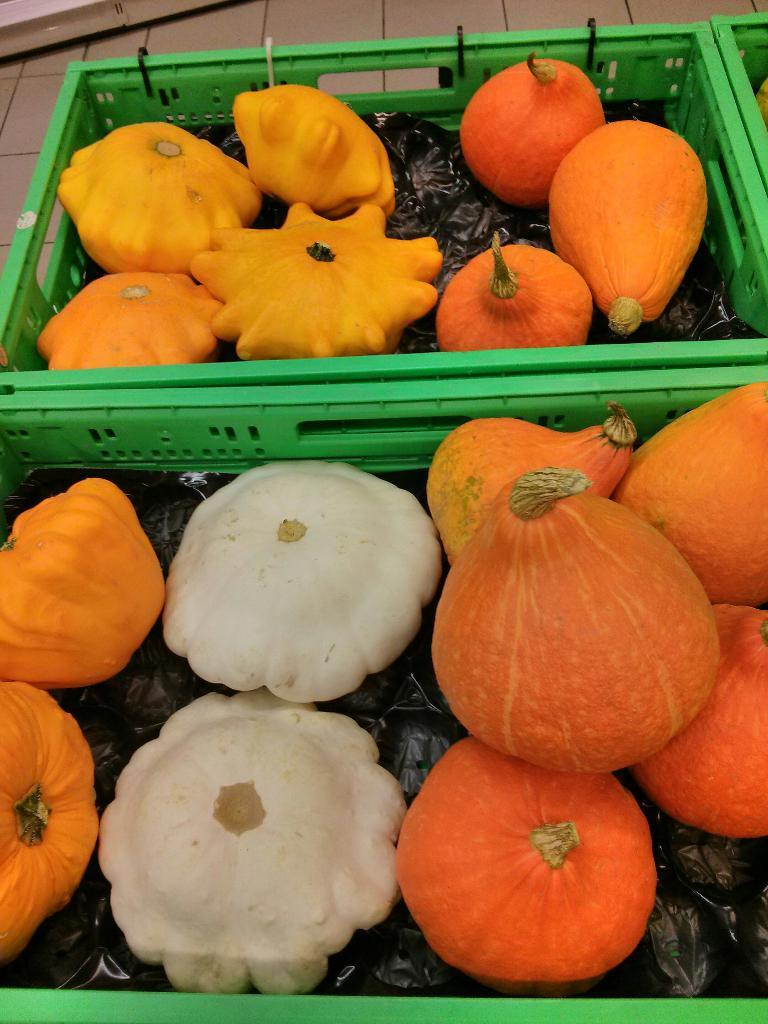What type of objects are present in the image? There are pumpkins in the image. How are the pumpkins arranged or contained in the image? The pumpkins are in a green basket. What type of trucks can be seen transporting the pumpkins in the image? There are no trucks present in the image; the pumpkins are in a green basket. What type of loss is depicted in the image? There is no loss depicted in the image; it features pumpkins in a green basket. 